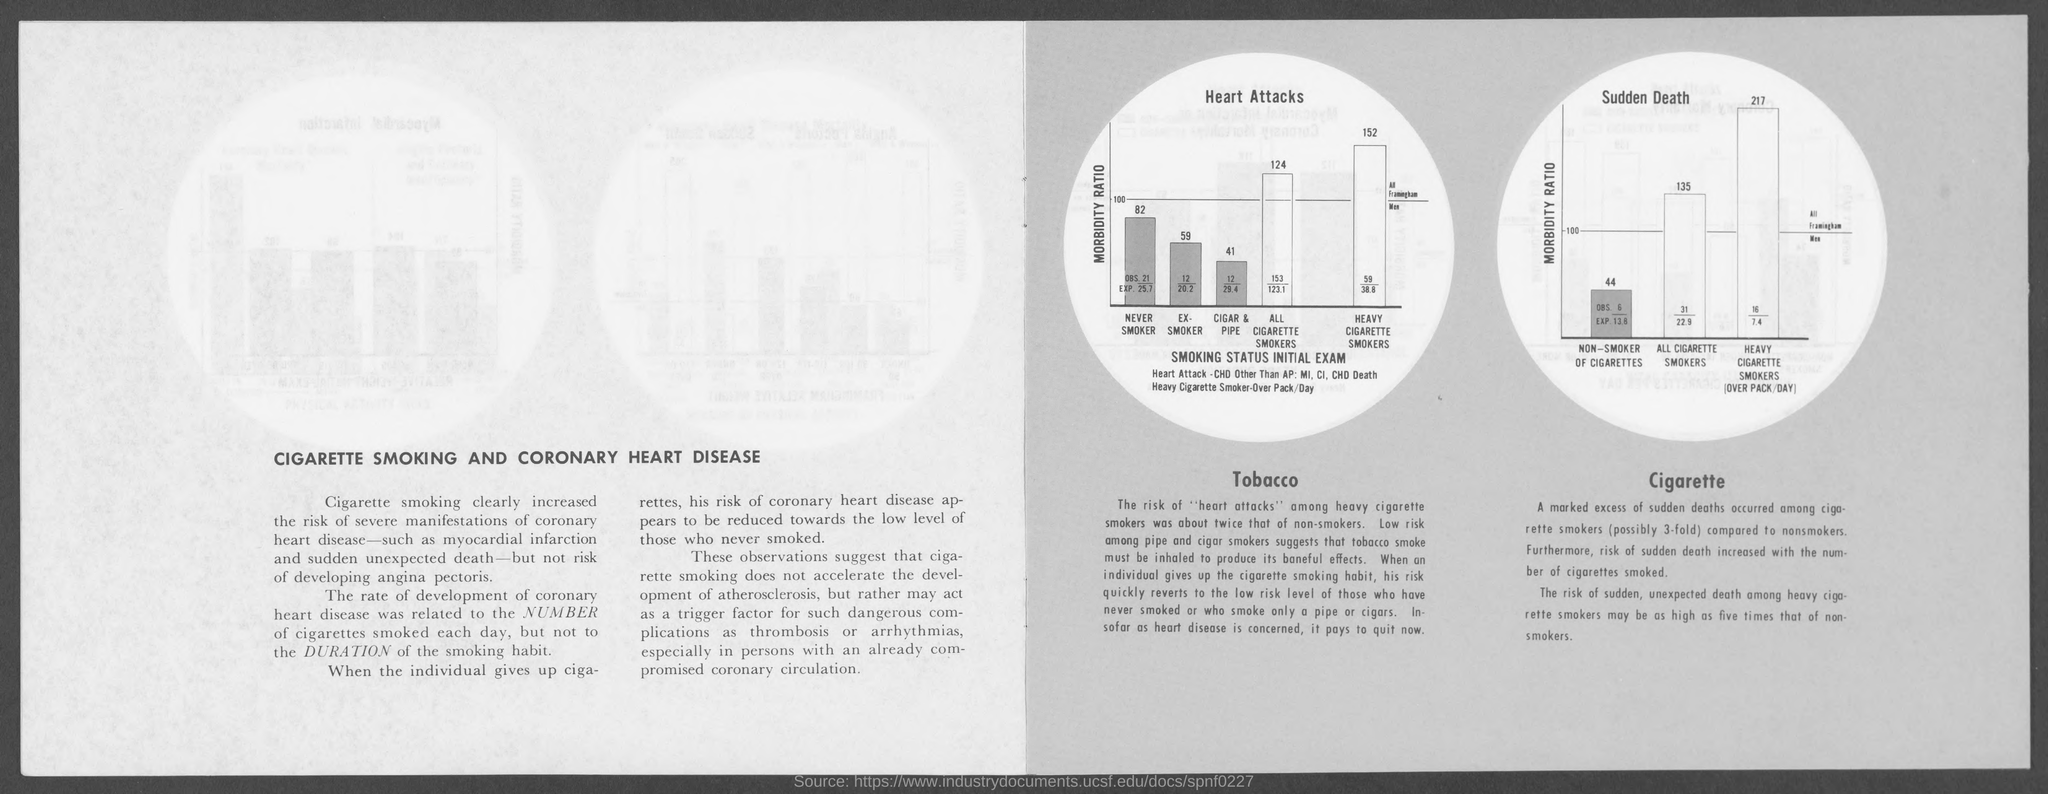What is the title of the text on the left hand side page?
Offer a very short reply. CIGARETTE SMOKING AND CORONARY HEART DISEASE. 